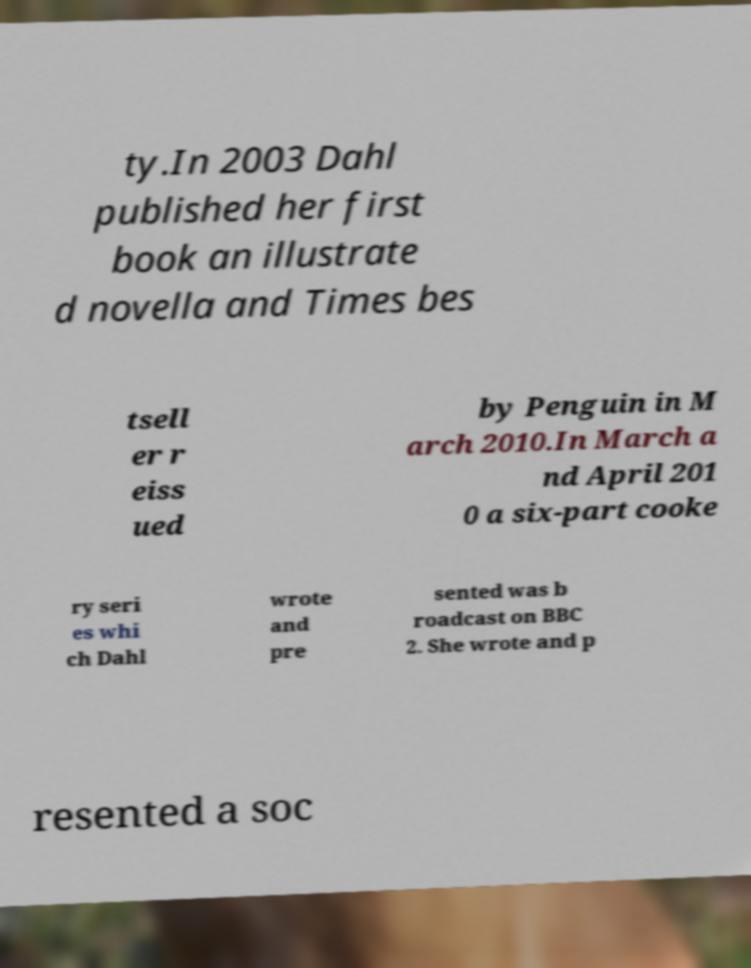Could you extract and type out the text from this image? ty.In 2003 Dahl published her first book an illustrate d novella and Times bes tsell er r eiss ued by Penguin in M arch 2010.In March a nd April 201 0 a six-part cooke ry seri es whi ch Dahl wrote and pre sented was b roadcast on BBC 2. She wrote and p resented a soc 